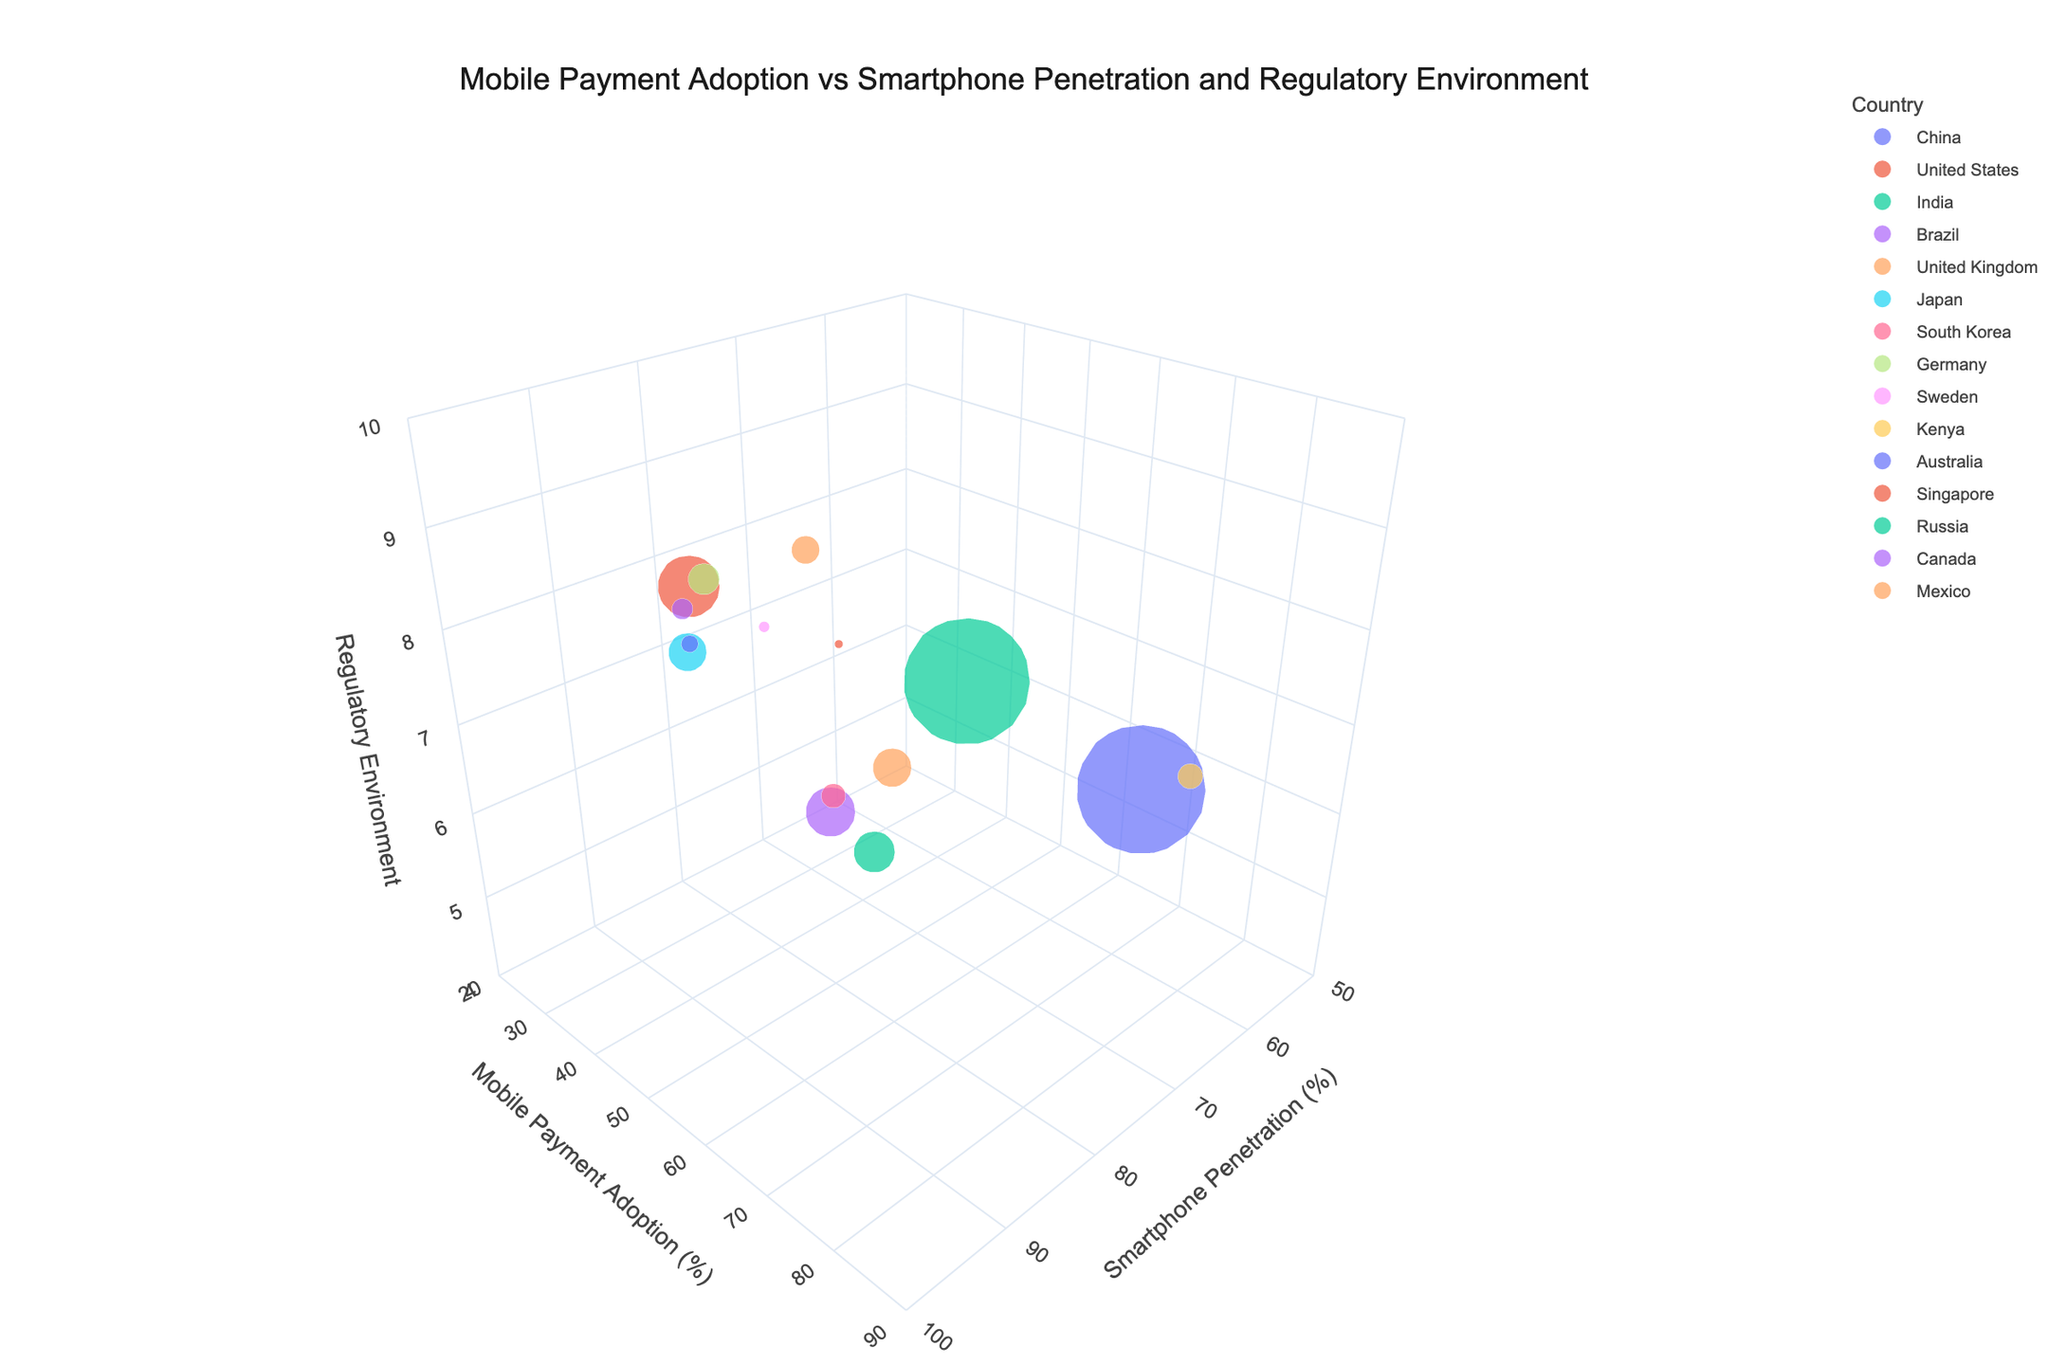What is the title of the figure? Look at the top of the figure to find the title. The title is usually prominently displayed.
Answer: Mobile Payment Adoption vs Smartphone Penetration and Regulatory Environment How many countries have a regulatory environment score of 9? Check for data points on the z-axis which marks the Regulatory Environment Score (1-10) at the value 9 and count them.
Answer: 3 (United Kingdom, Sweden, Singapore) Which country has the highest mobile payment adoption? Find the data point positioned highest on the y-axis, which represents Mobile Payment Adoption (%).
Answer: China Compare smartphone penetration between the United States and Sweden. Which country has higher penetration? Locate the data points for the United States and Sweden on the x-axis and compare their respective values.
Answer: Sweden What is the regulatory environment score for India? Find the data point for India on the z-axis and note the Regulatory Environment Score value.
Answer: 6 Which country has the largest bubble size in the figure? The size of the bubble corresponds to the population; the largest bubble will represent the largest population.
Answer: China Identify the country with the lowest mobile payment adoption and specify its value. Locate the data point lowest on the y-axis to find the country and note the Mobile Payment Adoption (%) value.
Answer: Japan, 23.5% What is the combined smartphone penetration percentage of Brazil and Mexico? Add the smartphone penetration percentages of Brazil (70.4%) and Mexico (60.9%).
Answer: 131.3% Which country has a better regulatory environment, Russia or Brazil? Compare the Regulatory Environment Scores of Russia and Brazil on the z-axis.
Answer: Russia How many countries have a mobile payment adoption rate above 50%? Identify and count data points with y-axis values (Mobile Payment Adoption %) above 50%.
Answer: 5 (China, United Kingdom, South Korea, Sweden, Kenya) 